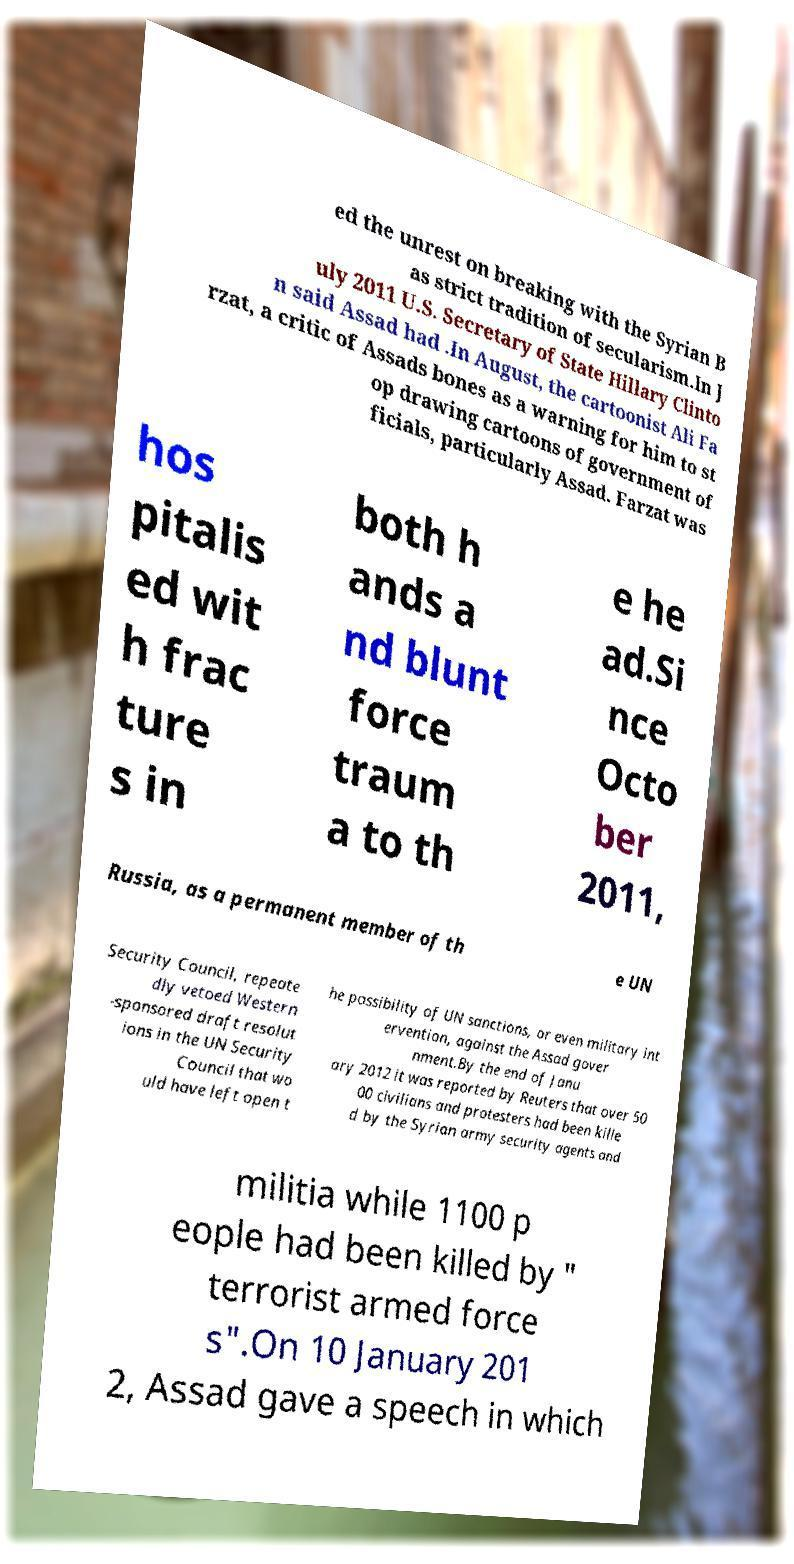Can you accurately transcribe the text from the provided image for me? ed the unrest on breaking with the Syrian B as strict tradition of secularism.In J uly 2011 U.S. Secretary of State Hillary Clinto n said Assad had .In August, the cartoonist Ali Fa rzat, a critic of Assads bones as a warning for him to st op drawing cartoons of government of ficials, particularly Assad. Farzat was hos pitalis ed wit h frac ture s in both h ands a nd blunt force traum a to th e he ad.Si nce Octo ber 2011, Russia, as a permanent member of th e UN Security Council, repeate dly vetoed Western -sponsored draft resolut ions in the UN Security Council that wo uld have left open t he possibility of UN sanctions, or even military int ervention, against the Assad gover nment.By the end of Janu ary 2012 it was reported by Reuters that over 50 00 civilians and protesters had been kille d by the Syrian army security agents and militia while 1100 p eople had been killed by " terrorist armed force s".On 10 January 201 2, Assad gave a speech in which 